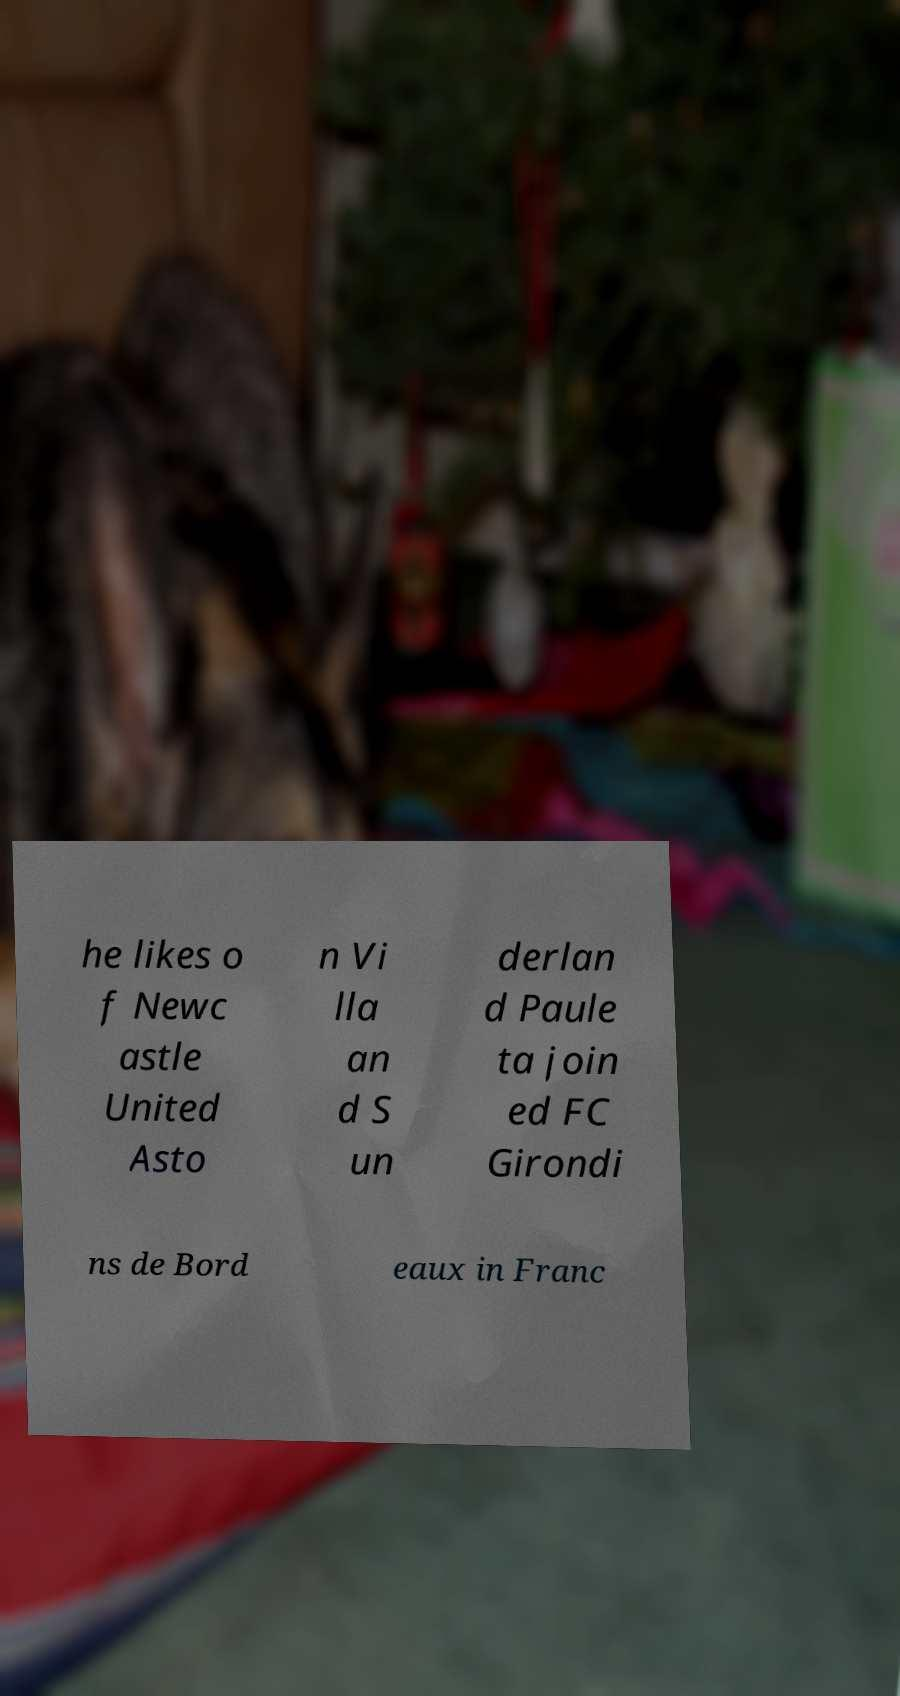There's text embedded in this image that I need extracted. Can you transcribe it verbatim? he likes o f Newc astle United Asto n Vi lla an d S un derlan d Paule ta join ed FC Girondi ns de Bord eaux in Franc 